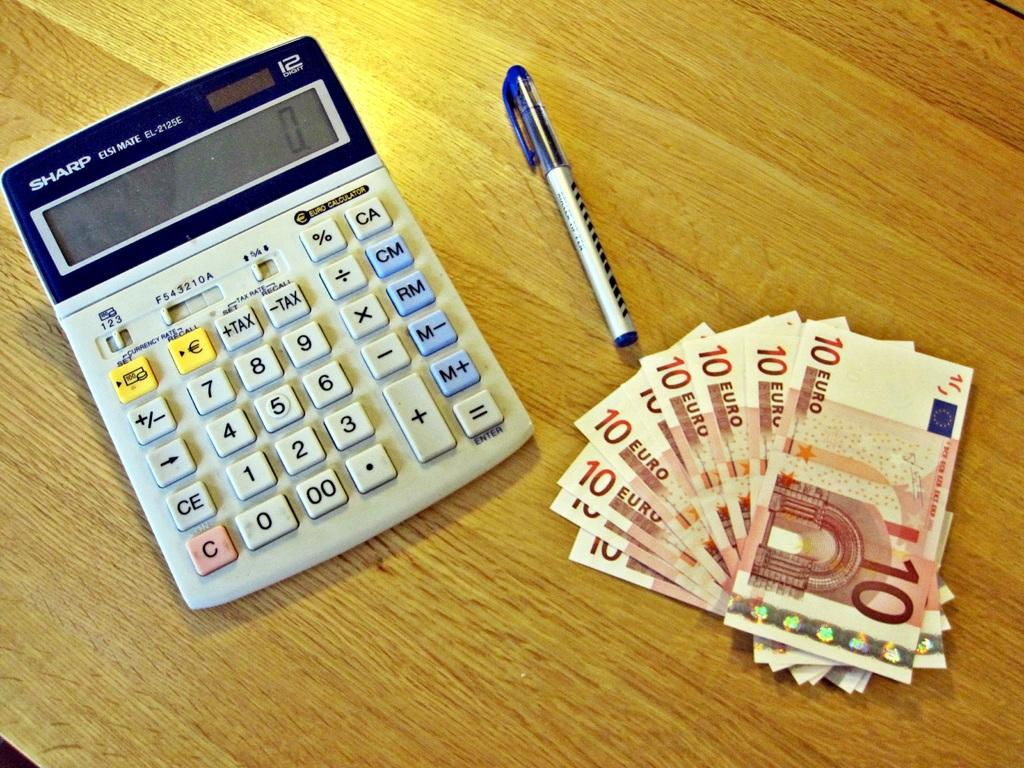<image>
Summarize the visual content of the image. A Sharp calculator set to zero, a pen with a blue cap, and a stack of 10 Euro bills. 